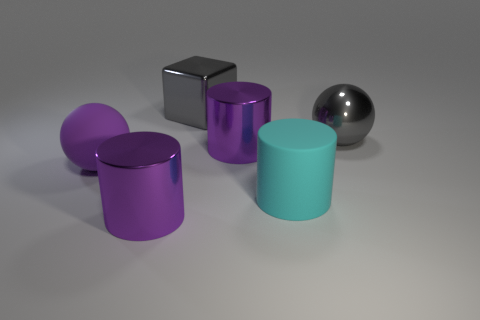Add 3 big matte cylinders. How many objects exist? 9 Subtract all cubes. How many objects are left? 5 Add 3 large gray metallic blocks. How many large gray metallic blocks are left? 4 Add 3 big purple cylinders. How many big purple cylinders exist? 5 Subtract 1 gray balls. How many objects are left? 5 Subtract all gray balls. Subtract all large purple objects. How many objects are left? 2 